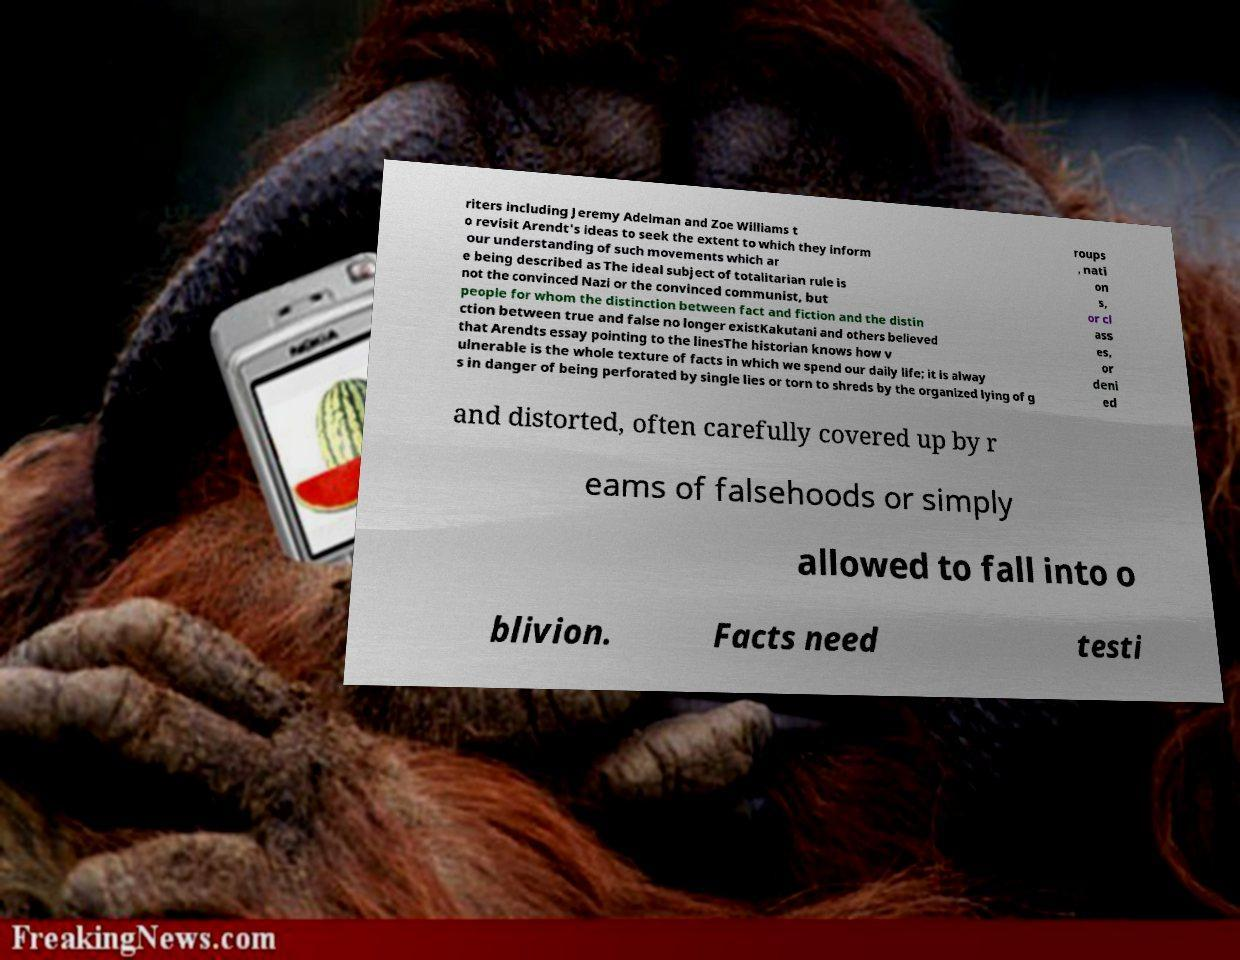What messages or text are displayed in this image? I need them in a readable, typed format. riters including Jeremy Adelman and Zoe Williams t o revisit Arendt's ideas to seek the extent to which they inform our understanding of such movements which ar e being described as The ideal subject of totalitarian rule is not the convinced Nazi or the convinced communist, but people for whom the distinction between fact and fiction and the distin ction between true and false no longer existKakutani and others believed that Arendts essay pointing to the linesThe historian knows how v ulnerable is the whole texture of facts in which we spend our daily life; it is alway s in danger of being perforated by single lies or torn to shreds by the organized lying of g roups , nati on s, or cl ass es, or deni ed and distorted, often carefully covered up by r eams of falsehoods or simply allowed to fall into o blivion. Facts need testi 